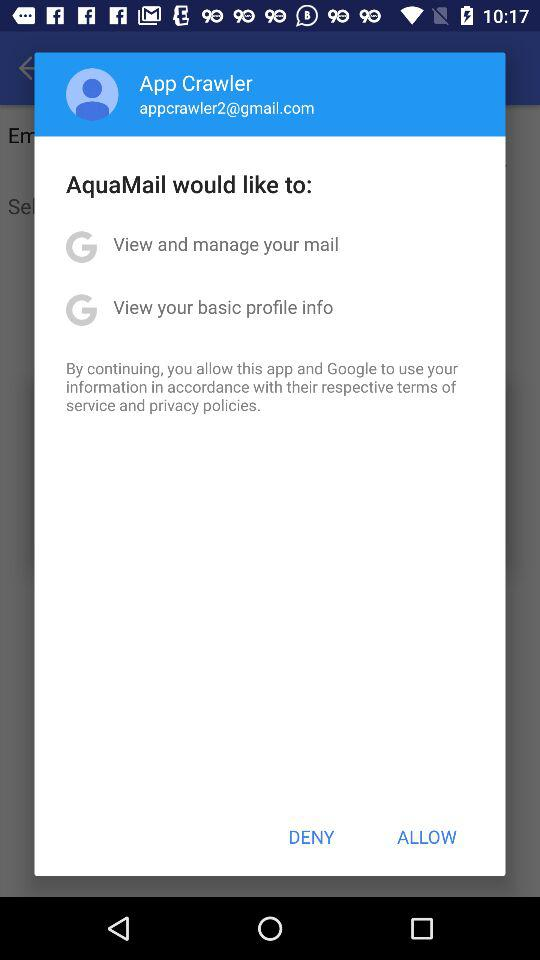What is the user's name? The user's name is App Crawler. 